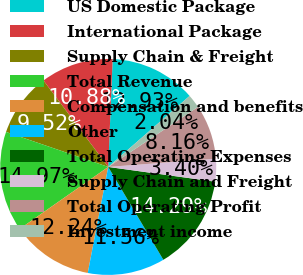Convert chart. <chart><loc_0><loc_0><loc_500><loc_500><pie_chart><fcel>US Domestic Package<fcel>International Package<fcel>Supply Chain & Freight<fcel>Total Revenue<fcel>Compensation and benefits<fcel>Other<fcel>Total Operating Expenses<fcel>Supply Chain and Freight<fcel>Total Operating Profit<fcel>Investment income<nl><fcel>12.93%<fcel>10.88%<fcel>9.52%<fcel>14.97%<fcel>12.24%<fcel>11.56%<fcel>14.29%<fcel>3.4%<fcel>8.16%<fcel>2.04%<nl></chart> 